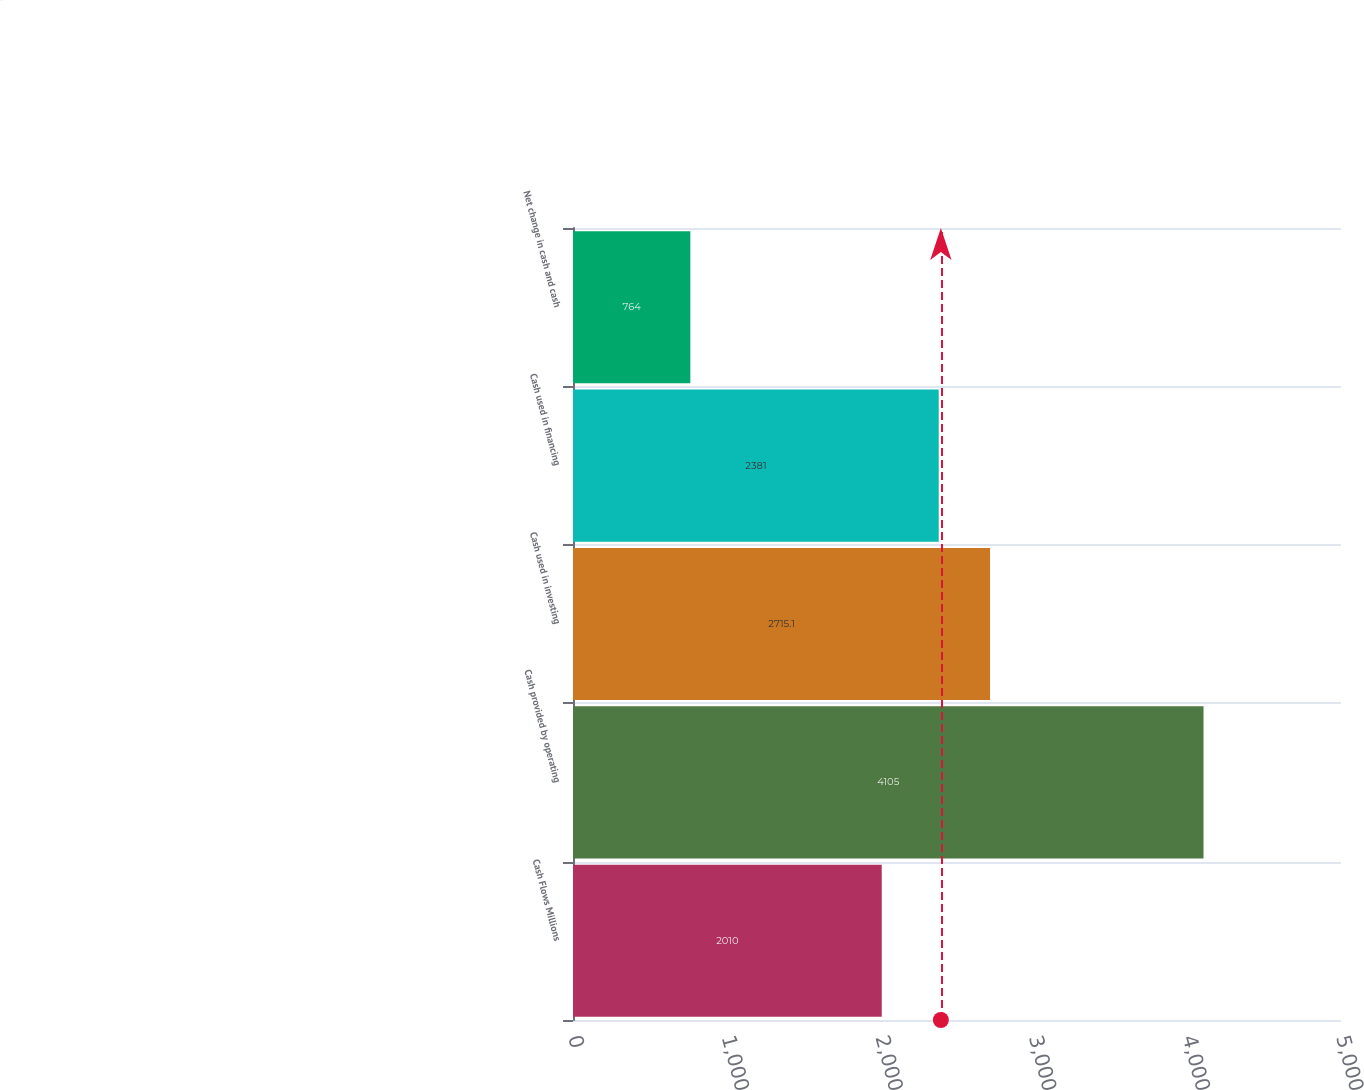<chart> <loc_0><loc_0><loc_500><loc_500><bar_chart><fcel>Cash Flows Millions<fcel>Cash provided by operating<fcel>Cash used in investing<fcel>Cash used in financing<fcel>Net change in cash and cash<nl><fcel>2010<fcel>4105<fcel>2715.1<fcel>2381<fcel>764<nl></chart> 